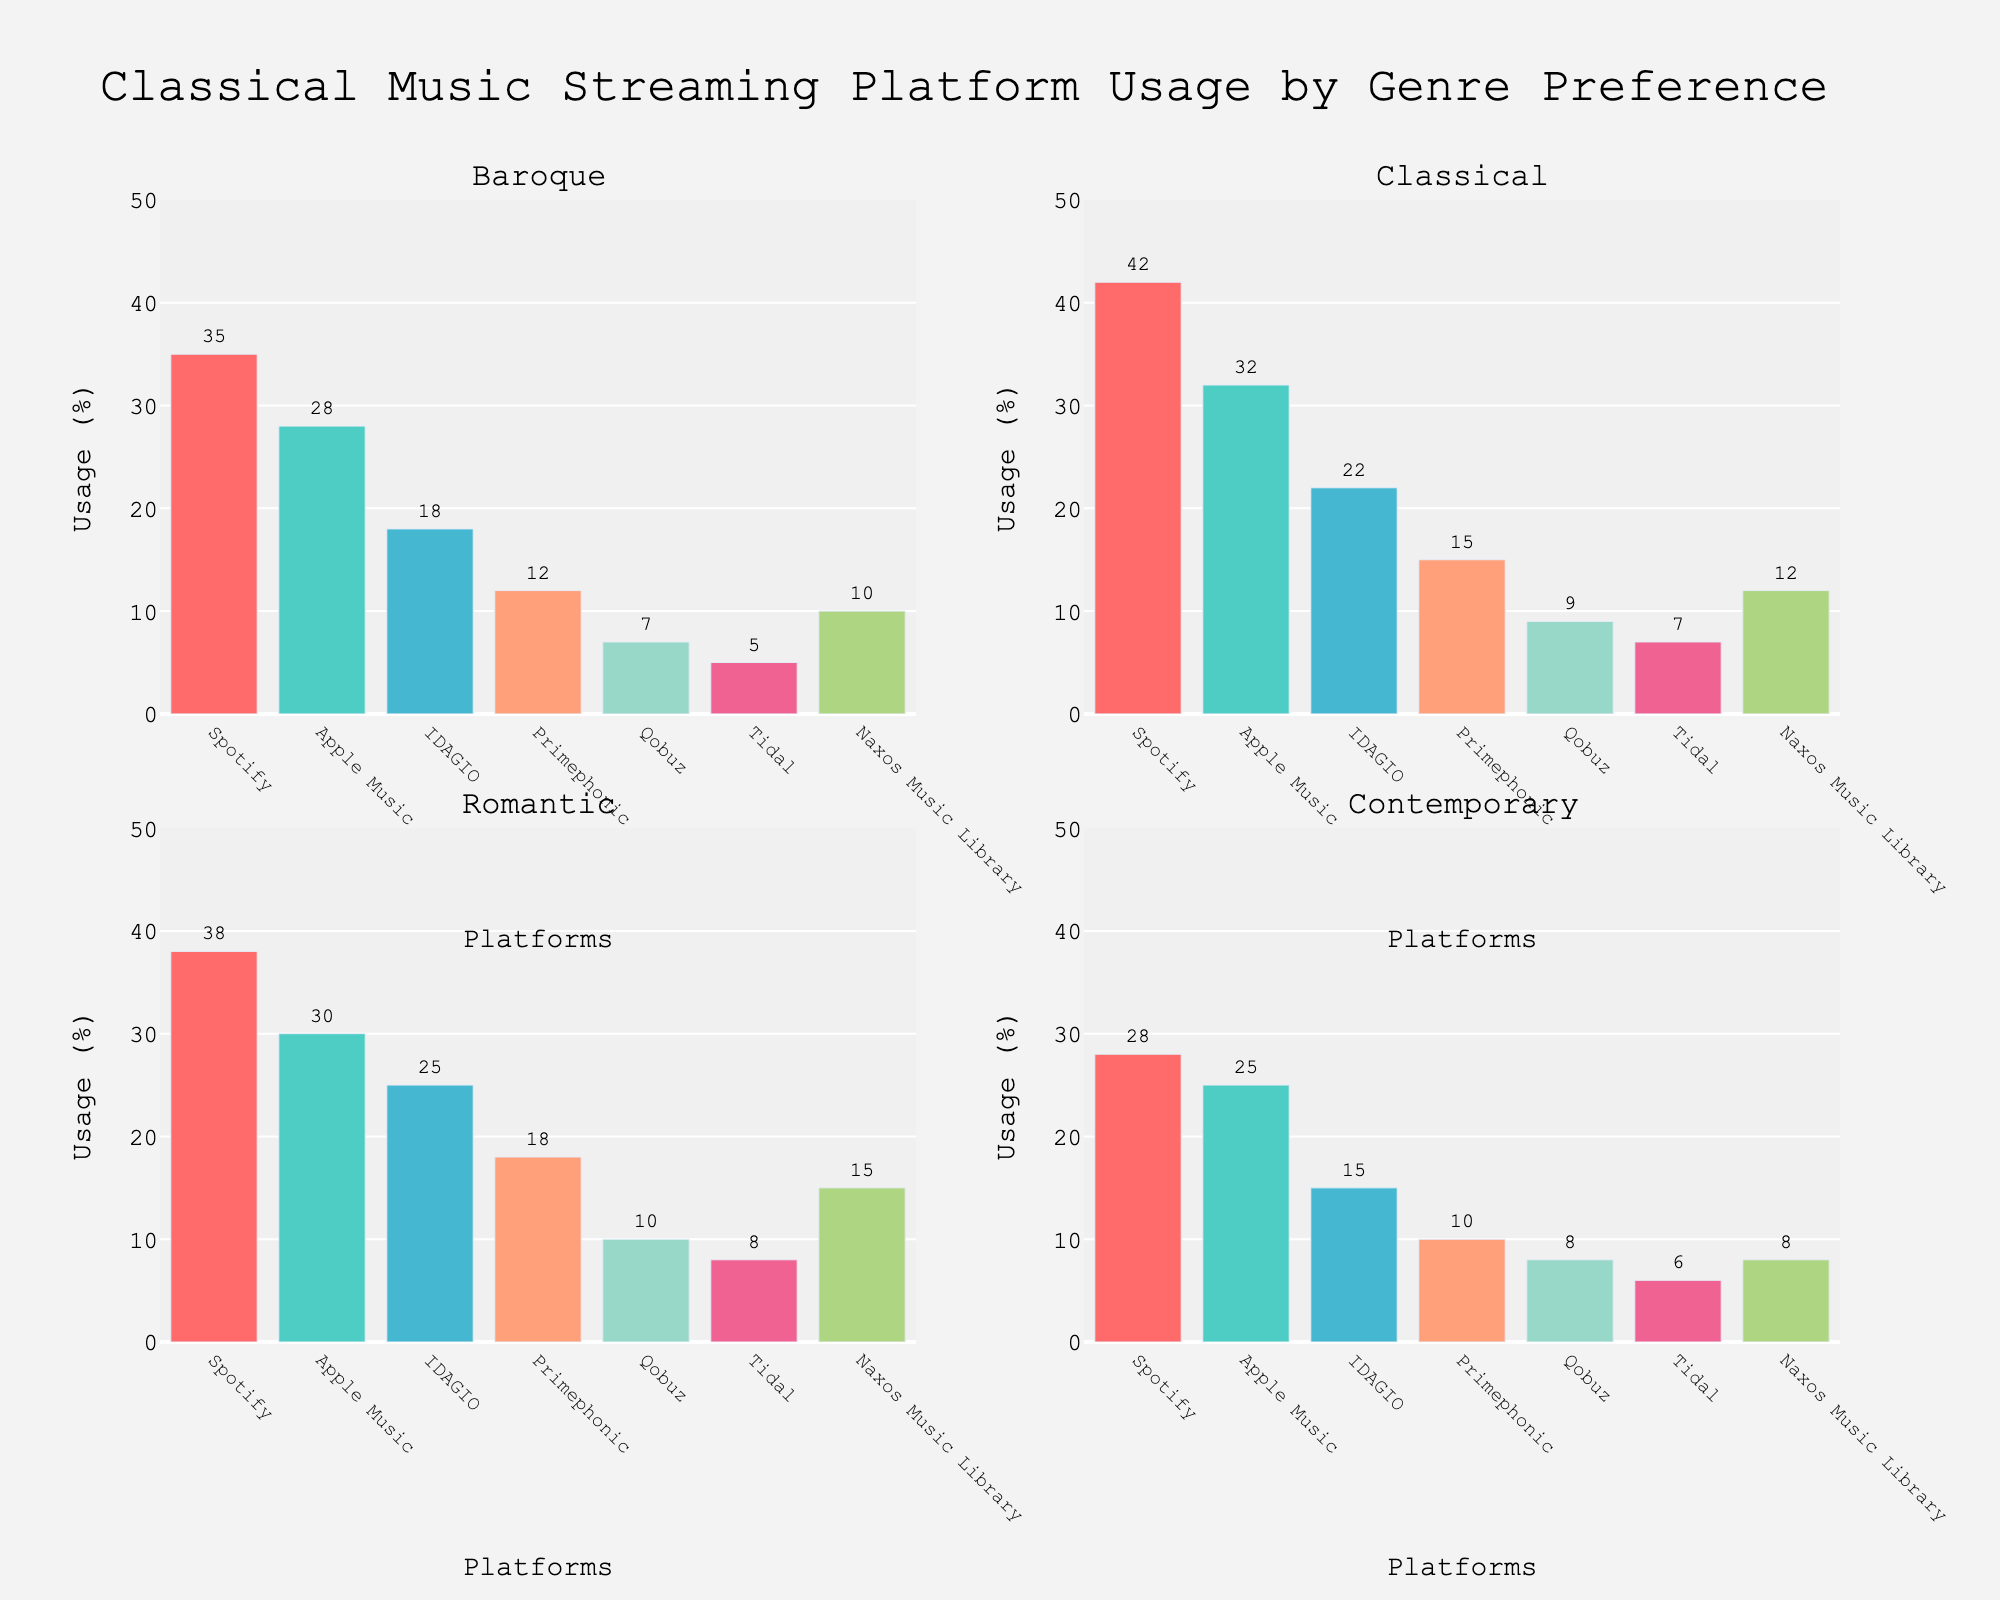What's the title of the figure? The title of the figure can be found at the top of the plot, clearly indicating the main topic.
Answer: Classical Music Streaming Platform Usage by Genre Preference Which platform has the highest usage among Classical genre listeners? By looking at the subplot for Classical genre, the highest bar indicates the platform with the highest usage.
Answer: Spotify What is the combined usage percentage of Qobuz and Tidal for the Baroque genre? In the Baroque subplot, add the usage percentages of Qobuz and Tidal: 7% + 5% = 12%
Answer: 12% Among Romantic genre listeners, how much more popular is IDAGIO compared to Naxos Music Library? Referring to the Romantic subplot, subtract the usage percentage of Naxos Music Library from that of IDAGIO: 25% - 15% = 10%
Answer: 10% Which genre has the lowest usage percentage for Primephonic? Look at the lowest bar for Primephonic in each genre subplot and compare them: 10% (Contemporary), 12% (Baroque), 15% (Classical), 18% (Romantic).
Answer: Contemporary Compare the usage of Apple Music and IDAGIO for Contemporary genre. Which one is used more and by how much? In the Contemporary subplot, subtract the usage percentage of IDAGIO from that of Apple Music: 25% - 15% = 10%. Apple Music has higher usage.
Answer: Apple Music by 10% What is the range of the y-axes in all subplots? The y-axis range can be found on the left side of any subplot, which is marked from 0 to 50.
Answer: 0 to 50 Across all genres, which platform shows a consistent increase in usage as the preference moves from Baroque to Romantic? Identify the platform with bars increasing from Baroque, Classical, to Romantic subplots.
Answer: IDAGIO How does the usage of Naxos Music Library in the Contemporary genre compare with its usage in the Classical genre? In the Contemporary subplot, Naxos Music Library is at 8%, while in the Classical subplot, it stands at 12%.
Answer: Less by 4% What is the difference between the highest and lowest usage percentages for any platform in the Classical genre subplot? In the Classical subplot, the highest usage is Spotify at 42% and the lowest is Tidal at 7%. Calculate the difference: 42% - 7% = 35%
Answer: 35% 